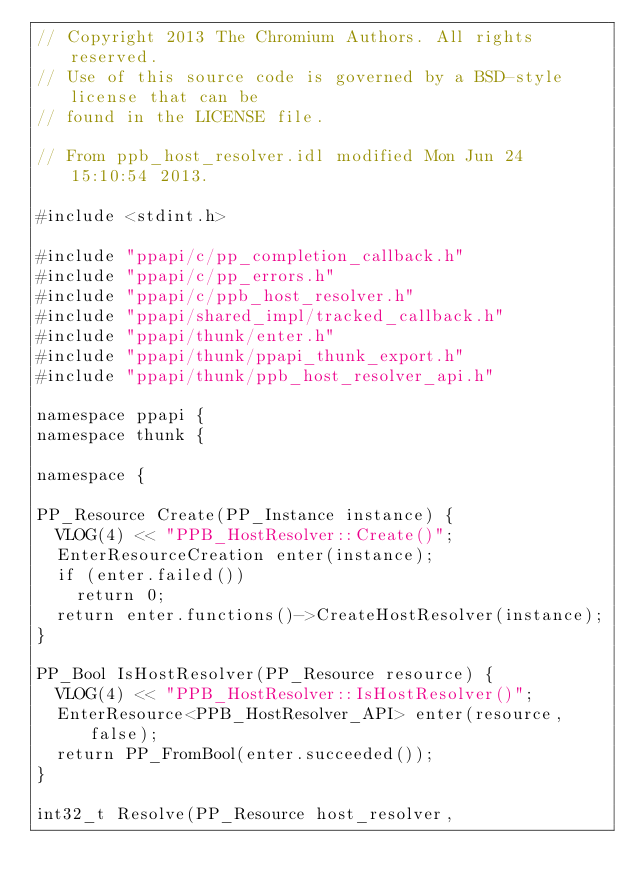<code> <loc_0><loc_0><loc_500><loc_500><_C++_>// Copyright 2013 The Chromium Authors. All rights reserved.
// Use of this source code is governed by a BSD-style license that can be
// found in the LICENSE file.

// From ppb_host_resolver.idl modified Mon Jun 24 15:10:54 2013.

#include <stdint.h>

#include "ppapi/c/pp_completion_callback.h"
#include "ppapi/c/pp_errors.h"
#include "ppapi/c/ppb_host_resolver.h"
#include "ppapi/shared_impl/tracked_callback.h"
#include "ppapi/thunk/enter.h"
#include "ppapi/thunk/ppapi_thunk_export.h"
#include "ppapi/thunk/ppb_host_resolver_api.h"

namespace ppapi {
namespace thunk {

namespace {

PP_Resource Create(PP_Instance instance) {
  VLOG(4) << "PPB_HostResolver::Create()";
  EnterResourceCreation enter(instance);
  if (enter.failed())
    return 0;
  return enter.functions()->CreateHostResolver(instance);
}

PP_Bool IsHostResolver(PP_Resource resource) {
  VLOG(4) << "PPB_HostResolver::IsHostResolver()";
  EnterResource<PPB_HostResolver_API> enter(resource, false);
  return PP_FromBool(enter.succeeded());
}

int32_t Resolve(PP_Resource host_resolver,</code> 